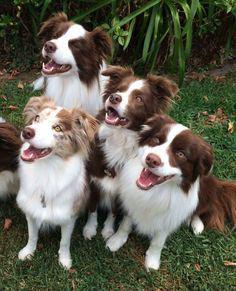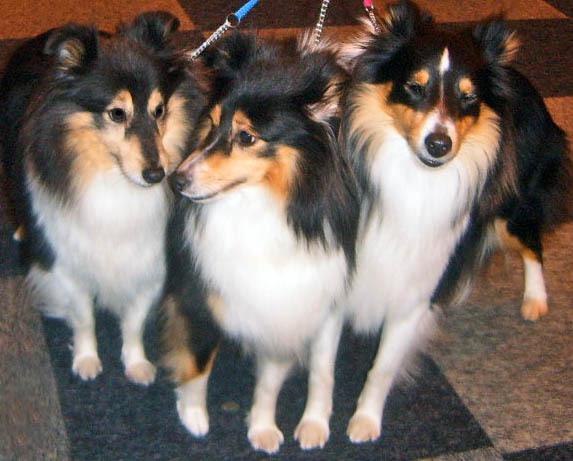The first image is the image on the left, the second image is the image on the right. Assess this claim about the two images: "An image shows a straight row of at least seven dogs reclining on the grass.". Correct or not? Answer yes or no. No. The first image is the image on the left, the second image is the image on the right. For the images shown, is this caption "There are at most 5 dogs on the left image." true? Answer yes or no. Yes. 